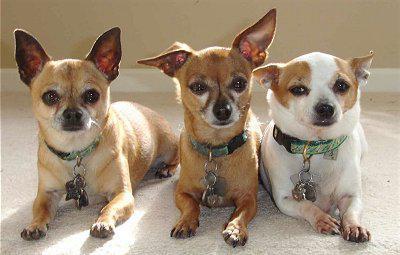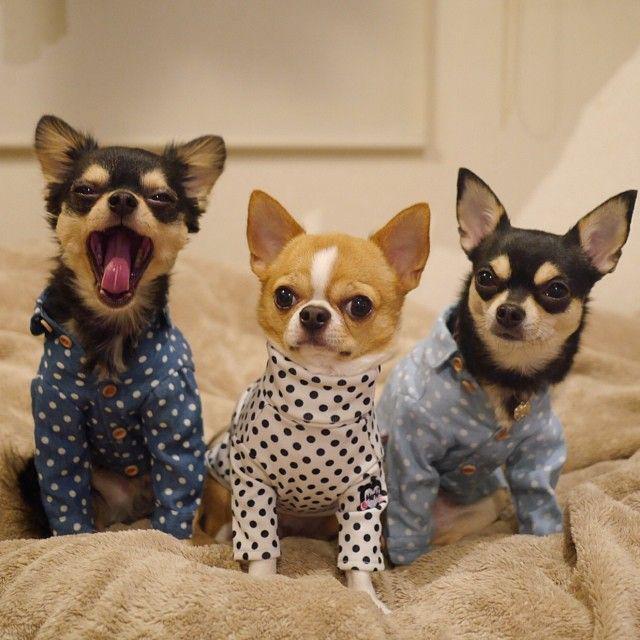The first image is the image on the left, the second image is the image on the right. Considering the images on both sides, is "Each image contains three dogs, and one set of dogs pose wearing only collars." valid? Answer yes or no. Yes. 